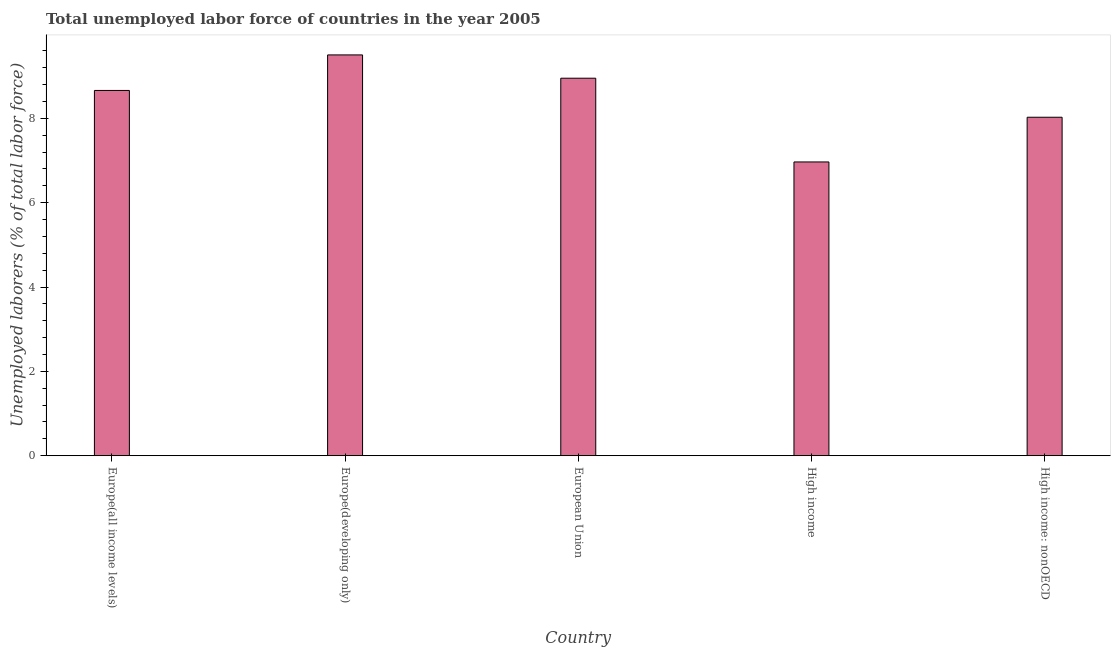Does the graph contain any zero values?
Ensure brevity in your answer.  No. Does the graph contain grids?
Provide a short and direct response. No. What is the title of the graph?
Your answer should be very brief. Total unemployed labor force of countries in the year 2005. What is the label or title of the X-axis?
Your answer should be compact. Country. What is the label or title of the Y-axis?
Provide a succinct answer. Unemployed laborers (% of total labor force). What is the total unemployed labour force in High income?
Your answer should be compact. 6.97. Across all countries, what is the maximum total unemployed labour force?
Offer a terse response. 9.5. Across all countries, what is the minimum total unemployed labour force?
Give a very brief answer. 6.97. In which country was the total unemployed labour force maximum?
Provide a succinct answer. Europe(developing only). In which country was the total unemployed labour force minimum?
Your answer should be compact. High income. What is the sum of the total unemployed labour force?
Offer a terse response. 42.11. What is the difference between the total unemployed labour force in Europe(developing only) and European Union?
Give a very brief answer. 0.55. What is the average total unemployed labour force per country?
Make the answer very short. 8.42. What is the median total unemployed labour force?
Provide a short and direct response. 8.66. What is the ratio of the total unemployed labour force in Europe(developing only) to that in High income?
Provide a succinct answer. 1.36. Is the total unemployed labour force in Europe(all income levels) less than that in Europe(developing only)?
Give a very brief answer. Yes. Is the difference between the total unemployed labour force in Europe(all income levels) and Europe(developing only) greater than the difference between any two countries?
Your answer should be very brief. No. What is the difference between the highest and the second highest total unemployed labour force?
Keep it short and to the point. 0.55. Is the sum of the total unemployed labour force in European Union and High income: nonOECD greater than the maximum total unemployed labour force across all countries?
Ensure brevity in your answer.  Yes. What is the difference between the highest and the lowest total unemployed labour force?
Ensure brevity in your answer.  2.54. How many bars are there?
Ensure brevity in your answer.  5. Are all the bars in the graph horizontal?
Keep it short and to the point. No. How many countries are there in the graph?
Give a very brief answer. 5. Are the values on the major ticks of Y-axis written in scientific E-notation?
Offer a very short reply. No. What is the Unemployed laborers (% of total labor force) in Europe(all income levels)?
Keep it short and to the point. 8.66. What is the Unemployed laborers (% of total labor force) of Europe(developing only)?
Offer a terse response. 9.5. What is the Unemployed laborers (% of total labor force) in European Union?
Provide a succinct answer. 8.95. What is the Unemployed laborers (% of total labor force) of High income?
Offer a very short reply. 6.97. What is the Unemployed laborers (% of total labor force) of High income: nonOECD?
Keep it short and to the point. 8.03. What is the difference between the Unemployed laborers (% of total labor force) in Europe(all income levels) and Europe(developing only)?
Keep it short and to the point. -0.84. What is the difference between the Unemployed laborers (% of total labor force) in Europe(all income levels) and European Union?
Give a very brief answer. -0.29. What is the difference between the Unemployed laborers (% of total labor force) in Europe(all income levels) and High income?
Ensure brevity in your answer.  1.7. What is the difference between the Unemployed laborers (% of total labor force) in Europe(all income levels) and High income: nonOECD?
Give a very brief answer. 0.64. What is the difference between the Unemployed laborers (% of total labor force) in Europe(developing only) and European Union?
Make the answer very short. 0.55. What is the difference between the Unemployed laborers (% of total labor force) in Europe(developing only) and High income?
Your response must be concise. 2.54. What is the difference between the Unemployed laborers (% of total labor force) in Europe(developing only) and High income: nonOECD?
Keep it short and to the point. 1.48. What is the difference between the Unemployed laborers (% of total labor force) in European Union and High income?
Your answer should be very brief. 1.99. What is the difference between the Unemployed laborers (% of total labor force) in European Union and High income: nonOECD?
Offer a very short reply. 0.93. What is the difference between the Unemployed laborers (% of total labor force) in High income and High income: nonOECD?
Provide a succinct answer. -1.06. What is the ratio of the Unemployed laborers (% of total labor force) in Europe(all income levels) to that in Europe(developing only)?
Make the answer very short. 0.91. What is the ratio of the Unemployed laborers (% of total labor force) in Europe(all income levels) to that in High income?
Keep it short and to the point. 1.24. What is the ratio of the Unemployed laborers (% of total labor force) in Europe(all income levels) to that in High income: nonOECD?
Provide a succinct answer. 1.08. What is the ratio of the Unemployed laborers (% of total labor force) in Europe(developing only) to that in European Union?
Provide a succinct answer. 1.06. What is the ratio of the Unemployed laborers (% of total labor force) in Europe(developing only) to that in High income?
Ensure brevity in your answer.  1.36. What is the ratio of the Unemployed laborers (% of total labor force) in Europe(developing only) to that in High income: nonOECD?
Provide a succinct answer. 1.18. What is the ratio of the Unemployed laborers (% of total labor force) in European Union to that in High income?
Your answer should be compact. 1.28. What is the ratio of the Unemployed laborers (% of total labor force) in European Union to that in High income: nonOECD?
Make the answer very short. 1.11. What is the ratio of the Unemployed laborers (% of total labor force) in High income to that in High income: nonOECD?
Give a very brief answer. 0.87. 